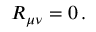<formula> <loc_0><loc_0><loc_500><loc_500>R _ { \mu \nu } = 0 \, .</formula> 